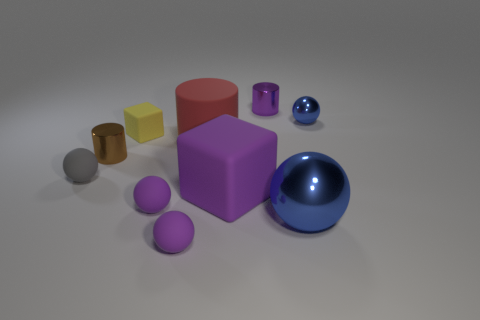There is a small shiny object that is the same shape as the big metallic thing; what color is it? blue 